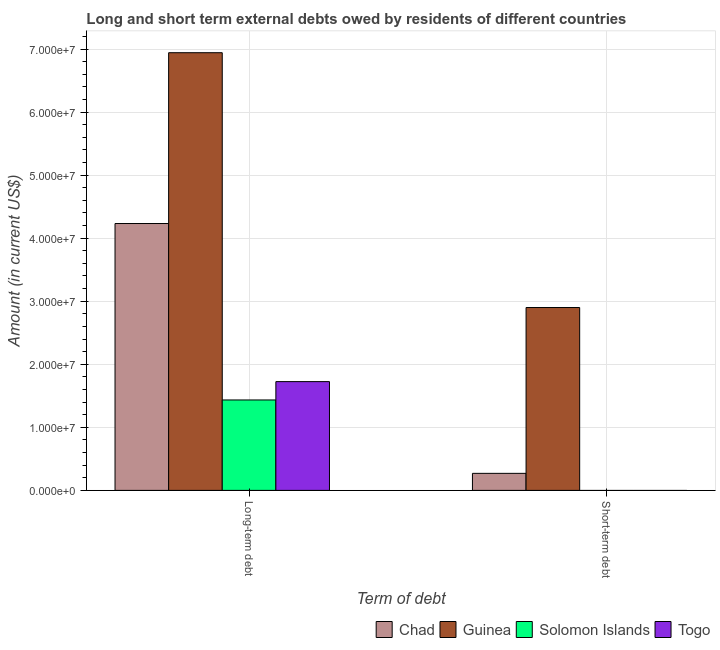How many groups of bars are there?
Your answer should be very brief. 2. Are the number of bars per tick equal to the number of legend labels?
Give a very brief answer. No. How many bars are there on the 2nd tick from the left?
Your answer should be compact. 2. What is the label of the 1st group of bars from the left?
Provide a short and direct response. Long-term debt. What is the short-term debts owed by residents in Guinea?
Your response must be concise. 2.90e+07. Across all countries, what is the maximum short-term debts owed by residents?
Give a very brief answer. 2.90e+07. Across all countries, what is the minimum long-term debts owed by residents?
Offer a very short reply. 1.43e+07. In which country was the short-term debts owed by residents maximum?
Keep it short and to the point. Guinea. What is the total short-term debts owed by residents in the graph?
Give a very brief answer. 3.17e+07. What is the difference between the long-term debts owed by residents in Chad and that in Togo?
Provide a succinct answer. 2.51e+07. What is the difference between the long-term debts owed by residents in Guinea and the short-term debts owed by residents in Solomon Islands?
Your response must be concise. 6.94e+07. What is the average long-term debts owed by residents per country?
Make the answer very short. 3.58e+07. What is the difference between the short-term debts owed by residents and long-term debts owed by residents in Guinea?
Your answer should be compact. -4.04e+07. In how many countries, is the long-term debts owed by residents greater than 50000000 US$?
Make the answer very short. 1. What is the ratio of the long-term debts owed by residents in Chad to that in Togo?
Your answer should be compact. 2.45. Is the long-term debts owed by residents in Guinea less than that in Togo?
Your response must be concise. No. In how many countries, is the long-term debts owed by residents greater than the average long-term debts owed by residents taken over all countries?
Provide a short and direct response. 2. Are the values on the major ticks of Y-axis written in scientific E-notation?
Provide a short and direct response. Yes. Does the graph contain any zero values?
Offer a very short reply. Yes. What is the title of the graph?
Your answer should be very brief. Long and short term external debts owed by residents of different countries. Does "Egypt, Arab Rep." appear as one of the legend labels in the graph?
Provide a short and direct response. No. What is the label or title of the X-axis?
Your response must be concise. Term of debt. What is the label or title of the Y-axis?
Your answer should be compact. Amount (in current US$). What is the Amount (in current US$) in Chad in Long-term debt?
Provide a short and direct response. 4.23e+07. What is the Amount (in current US$) in Guinea in Long-term debt?
Keep it short and to the point. 6.94e+07. What is the Amount (in current US$) in Solomon Islands in Long-term debt?
Provide a succinct answer. 1.43e+07. What is the Amount (in current US$) in Togo in Long-term debt?
Your answer should be very brief. 1.72e+07. What is the Amount (in current US$) of Chad in Short-term debt?
Your answer should be very brief. 2.70e+06. What is the Amount (in current US$) in Guinea in Short-term debt?
Provide a succinct answer. 2.90e+07. What is the Amount (in current US$) in Solomon Islands in Short-term debt?
Offer a terse response. 0. What is the Amount (in current US$) of Togo in Short-term debt?
Give a very brief answer. 0. Across all Term of debt, what is the maximum Amount (in current US$) of Chad?
Keep it short and to the point. 4.23e+07. Across all Term of debt, what is the maximum Amount (in current US$) of Guinea?
Provide a succinct answer. 6.94e+07. Across all Term of debt, what is the maximum Amount (in current US$) of Solomon Islands?
Keep it short and to the point. 1.43e+07. Across all Term of debt, what is the maximum Amount (in current US$) in Togo?
Your answer should be compact. 1.72e+07. Across all Term of debt, what is the minimum Amount (in current US$) of Chad?
Your answer should be very brief. 2.70e+06. Across all Term of debt, what is the minimum Amount (in current US$) of Guinea?
Give a very brief answer. 2.90e+07. Across all Term of debt, what is the minimum Amount (in current US$) in Togo?
Offer a very short reply. 0. What is the total Amount (in current US$) in Chad in the graph?
Offer a very short reply. 4.50e+07. What is the total Amount (in current US$) in Guinea in the graph?
Your answer should be compact. 9.84e+07. What is the total Amount (in current US$) in Solomon Islands in the graph?
Your answer should be compact. 1.43e+07. What is the total Amount (in current US$) of Togo in the graph?
Provide a short and direct response. 1.72e+07. What is the difference between the Amount (in current US$) of Chad in Long-term debt and that in Short-term debt?
Give a very brief answer. 3.96e+07. What is the difference between the Amount (in current US$) in Guinea in Long-term debt and that in Short-term debt?
Offer a terse response. 4.04e+07. What is the difference between the Amount (in current US$) of Chad in Long-term debt and the Amount (in current US$) of Guinea in Short-term debt?
Offer a terse response. 1.33e+07. What is the average Amount (in current US$) of Chad per Term of debt?
Give a very brief answer. 2.25e+07. What is the average Amount (in current US$) in Guinea per Term of debt?
Ensure brevity in your answer.  4.92e+07. What is the average Amount (in current US$) of Solomon Islands per Term of debt?
Make the answer very short. 7.17e+06. What is the average Amount (in current US$) of Togo per Term of debt?
Ensure brevity in your answer.  8.62e+06. What is the difference between the Amount (in current US$) of Chad and Amount (in current US$) of Guinea in Long-term debt?
Give a very brief answer. -2.71e+07. What is the difference between the Amount (in current US$) in Chad and Amount (in current US$) in Solomon Islands in Long-term debt?
Provide a succinct answer. 2.80e+07. What is the difference between the Amount (in current US$) of Chad and Amount (in current US$) of Togo in Long-term debt?
Give a very brief answer. 2.51e+07. What is the difference between the Amount (in current US$) in Guinea and Amount (in current US$) in Solomon Islands in Long-term debt?
Provide a short and direct response. 5.51e+07. What is the difference between the Amount (in current US$) of Guinea and Amount (in current US$) of Togo in Long-term debt?
Provide a succinct answer. 5.22e+07. What is the difference between the Amount (in current US$) of Solomon Islands and Amount (in current US$) of Togo in Long-term debt?
Offer a terse response. -2.91e+06. What is the difference between the Amount (in current US$) of Chad and Amount (in current US$) of Guinea in Short-term debt?
Ensure brevity in your answer.  -2.63e+07. What is the ratio of the Amount (in current US$) in Chad in Long-term debt to that in Short-term debt?
Your response must be concise. 15.67. What is the ratio of the Amount (in current US$) of Guinea in Long-term debt to that in Short-term debt?
Offer a terse response. 2.39. What is the difference between the highest and the second highest Amount (in current US$) of Chad?
Provide a short and direct response. 3.96e+07. What is the difference between the highest and the second highest Amount (in current US$) of Guinea?
Ensure brevity in your answer.  4.04e+07. What is the difference between the highest and the lowest Amount (in current US$) of Chad?
Your answer should be compact. 3.96e+07. What is the difference between the highest and the lowest Amount (in current US$) in Guinea?
Offer a very short reply. 4.04e+07. What is the difference between the highest and the lowest Amount (in current US$) of Solomon Islands?
Make the answer very short. 1.43e+07. What is the difference between the highest and the lowest Amount (in current US$) in Togo?
Make the answer very short. 1.72e+07. 